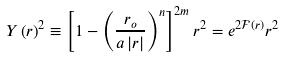<formula> <loc_0><loc_0><loc_500><loc_500>Y \left ( r \right ) ^ { 2 } \equiv \left [ 1 - \left ( \frac { r _ { o } } { a \left | r \right | } \right ) ^ { n } \right ] ^ { 2 m } r ^ { 2 } = e ^ { 2 \mathcal { F } \left ( r \right ) } r ^ { 2 }</formula> 